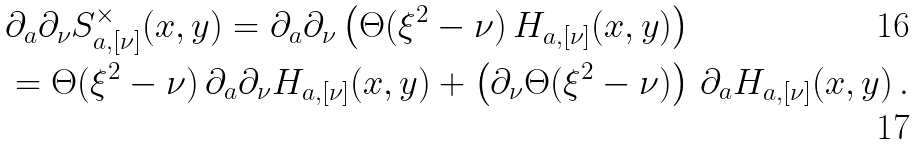<formula> <loc_0><loc_0><loc_500><loc_500>& \partial _ { a } \partial _ { \nu } S _ { a , [ \nu ] } ^ { \times } ( x , y ) = \partial _ { a } \partial _ { \nu } \left ( \Theta ( \xi ^ { 2 } - \nu ) \, H _ { a , [ \nu ] } ( x , y ) \right ) \\ & = \Theta ( \xi ^ { 2 } - \nu ) \, \partial _ { a } \partial _ { \nu } H _ { a , [ \nu ] } ( x , y ) + \left ( \partial _ { \nu } \Theta ( \xi ^ { 2 } - \nu ) \right ) \, \partial _ { a } H _ { a , [ \nu ] } ( x , y ) \, .</formula> 